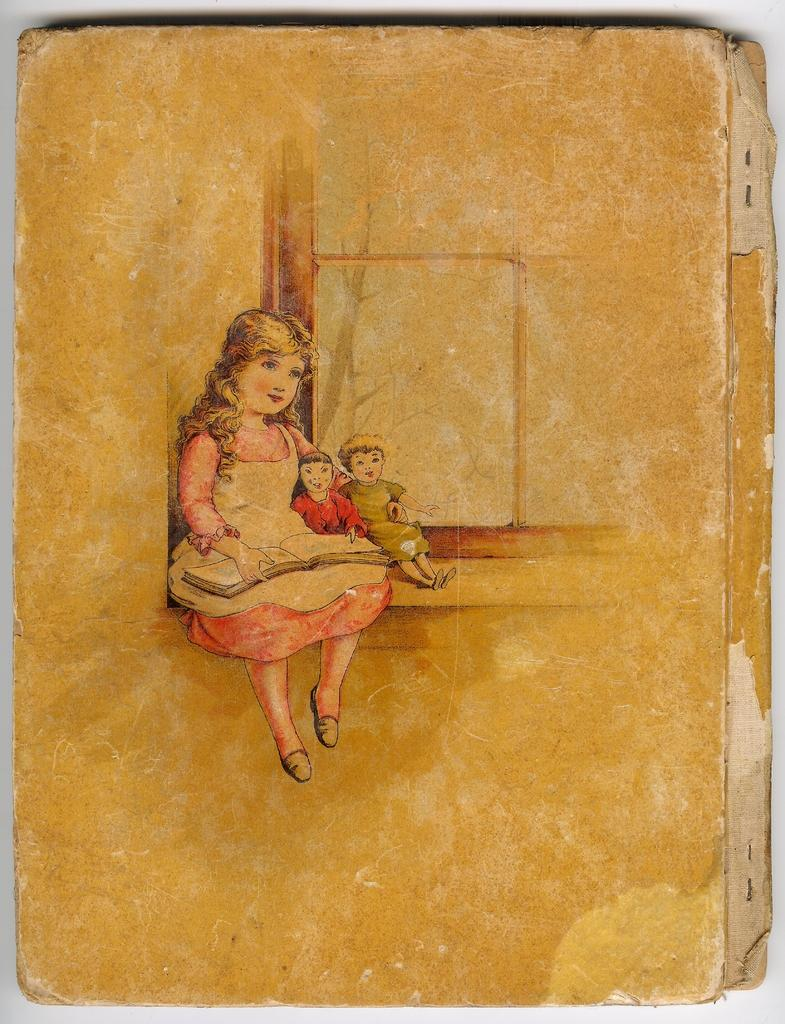What is the main object in the image? There is a cardboard sheet in the image. What is on the cardboard sheet? The cardboard sheet has a painting on it. What does the painting depict? The painting depicts a girl and two kids. Can you tell me where the dad is in the painting? There is no dad depicted in the painting; it only features a girl and two kids. What type of jewel is the girl wearing in the painting? There is no mention of a jewel in the painting; it only depicts a girl and two kids. 